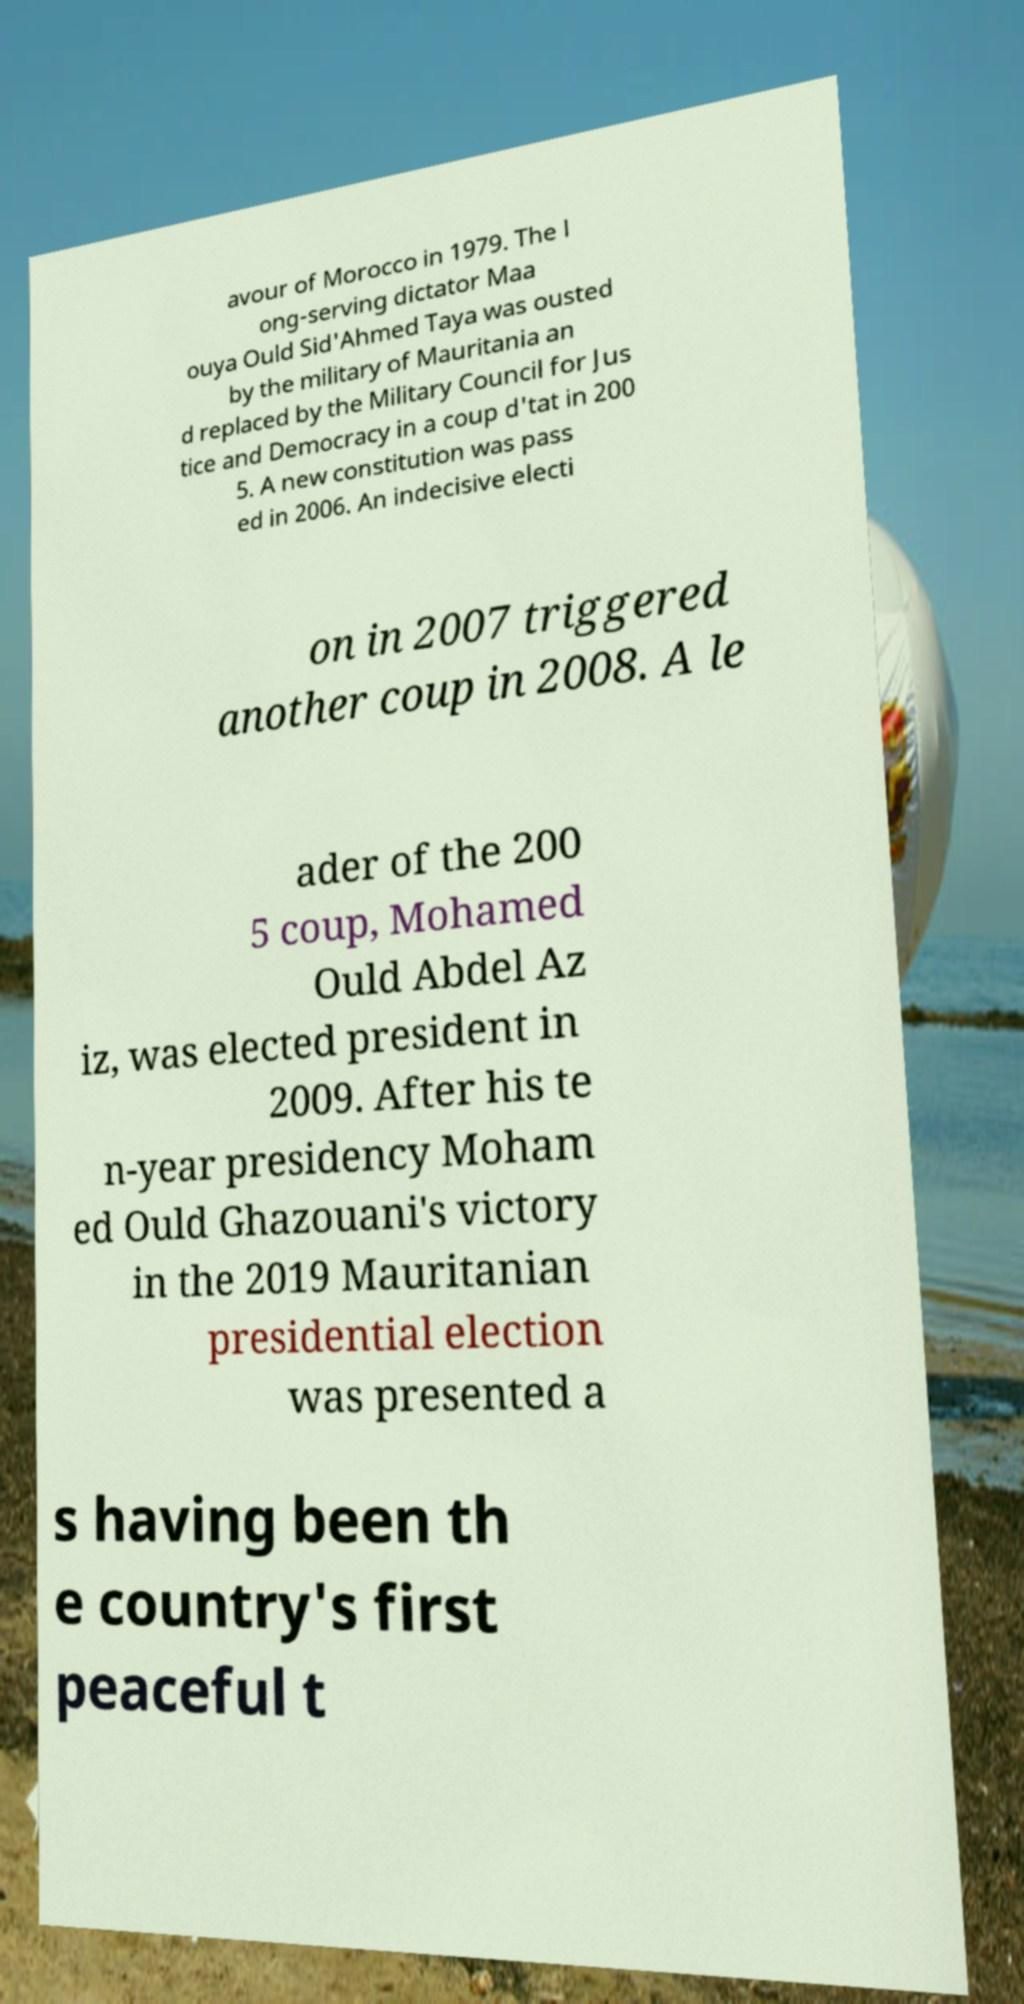Please identify and transcribe the text found in this image. avour of Morocco in 1979. The l ong-serving dictator Maa ouya Ould Sid'Ahmed Taya was ousted by the military of Mauritania an d replaced by the Military Council for Jus tice and Democracy in a coup d'tat in 200 5. A new constitution was pass ed in 2006. An indecisive electi on in 2007 triggered another coup in 2008. A le ader of the 200 5 coup, Mohamed Ould Abdel Az iz, was elected president in 2009. After his te n-year presidency Moham ed Ould Ghazouani's victory in the 2019 Mauritanian presidential election was presented a s having been th e country's first peaceful t 